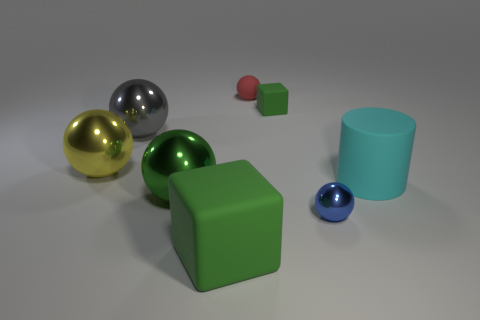Subtract all green cubes. How many were subtracted if there are1green cubes left? 1 Add 2 tiny yellow rubber blocks. How many objects exist? 10 Subtract all red balls. How many balls are left? 4 Subtract all red spheres. How many spheres are left? 4 Subtract all cubes. How many objects are left? 6 Subtract 1 balls. How many balls are left? 4 Subtract all green cylinders. How many blue balls are left? 1 Subtract all big green metallic objects. Subtract all large gray metallic spheres. How many objects are left? 6 Add 3 rubber cylinders. How many rubber cylinders are left? 4 Add 3 red matte objects. How many red matte objects exist? 4 